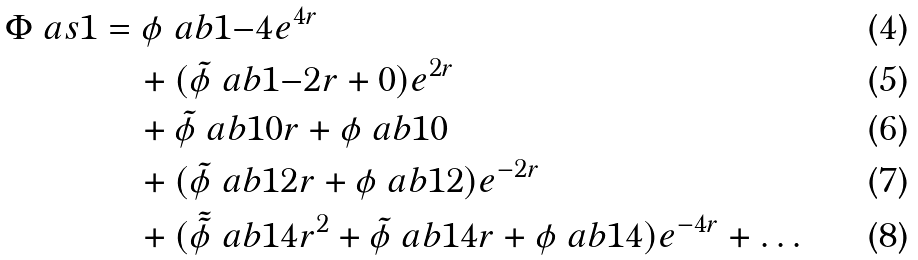Convert formula to latex. <formula><loc_0><loc_0><loc_500><loc_500>\Phi \ a s { 1 } & = \phi \ a b { 1 } { - 4 } e ^ { 4 r } \\ & \quad + ( \tilde { \phi } \ a b { 1 } { - 2 } r + 0 ) e ^ { 2 r } \\ & \quad + \tilde { \phi } \ a b { 1 } { 0 } r + \phi \ a b { 1 } { 0 } \\ & \quad + ( \tilde { \phi } \ a b { 1 } { 2 } r + \phi \ a b { 1 } { 2 } ) e ^ { - 2 r } \\ & \quad + ( \tilde { \tilde { \phi } } \ a b { 1 } { 4 } r ^ { 2 } + \tilde { \phi } \ a b { 1 } { 4 } r + \phi \ a b { 1 } { 4 } ) e ^ { - 4 r } + \dots</formula> 